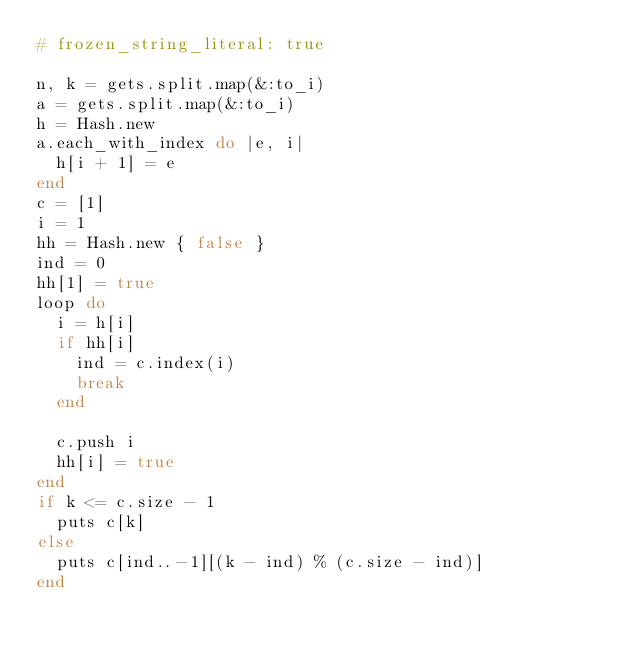<code> <loc_0><loc_0><loc_500><loc_500><_Ruby_># frozen_string_literal: true

n, k = gets.split.map(&:to_i)
a = gets.split.map(&:to_i)
h = Hash.new
a.each_with_index do |e, i|
  h[i + 1] = e
end
c = [1]
i = 1
hh = Hash.new { false }
ind = 0
hh[1] = true
loop do
  i = h[i]
  if hh[i]
    ind = c.index(i)
    break
  end

  c.push i
  hh[i] = true
end
if k <= c.size - 1
  puts c[k]
else
  puts c[ind..-1][(k - ind) % (c.size - ind)]
end
</code> 